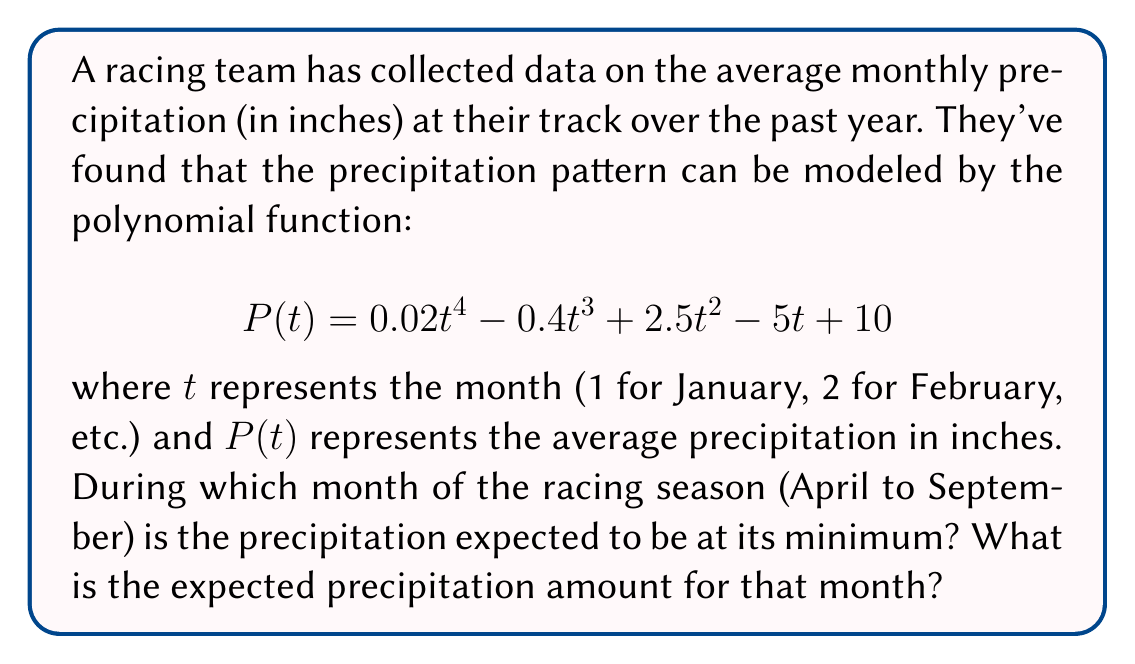Could you help me with this problem? To solve this problem, we need to follow these steps:

1) First, we need to find the derivative of $P(t)$ to determine where the function reaches its minimum:

   $$P'(t) = 0.08t^3 - 1.2t^2 + 5t - 5$$

2) The racing season is from April (t=4) to September (t=9). We need to check the values of $P'(t)$ for these months:

   $$P'(4) = 0.08(64) - 1.2(16) + 5(4) - 5 = 5.12 - 19.2 + 20 - 5 = 0.92$$
   $$P'(5) = 0.08(125) - 1.2(25) + 5(5) - 5 = 10 - 30 + 25 - 5 = 0$$
   $$P'(6) = 0.08(216) - 1.2(36) + 5(6) - 5 = 17.28 - 43.2 + 30 - 5 = -0.92$$
   $$P'(7) = 0.08(343) - 1.2(49) + 5(7) - 5 = 27.44 - 58.8 + 35 - 5 = -1.36$$
   $$P'(8) = 0.08(512) - 1.2(64) + 5(8) - 5 = 40.96 - 76.8 + 40 - 5 = -0.84$$
   $$P'(9) = 0.08(729) - 1.2(81) + 5(9) - 5 = 58.32 - 97.2 + 45 - 5 = 1.12$$

3) We can see that $P'(t)$ changes from positive to negative between t=5 and t=6, indicating a local maximum. It then remains negative until after t=9, suggesting the minimum occurs at t=9 (September).

4) To confirm and find the precipitation amount, we calculate $P(9)$:

   $$P(9) = 0.02(9^4) - 0.4(9^3) + 2.5(9^2) - 5(9) + 10$$
   $$= 0.02(6561) - 0.4(729) + 2.5(81) - 45 + 10$$
   $$= 131.22 - 291.6 + 202.5 - 45 + 10 = 7.12$$

Therefore, the minimum precipitation during the racing season occurs in September with an expected amount of 7.12 inches.
Answer: September, 7.12 inches 